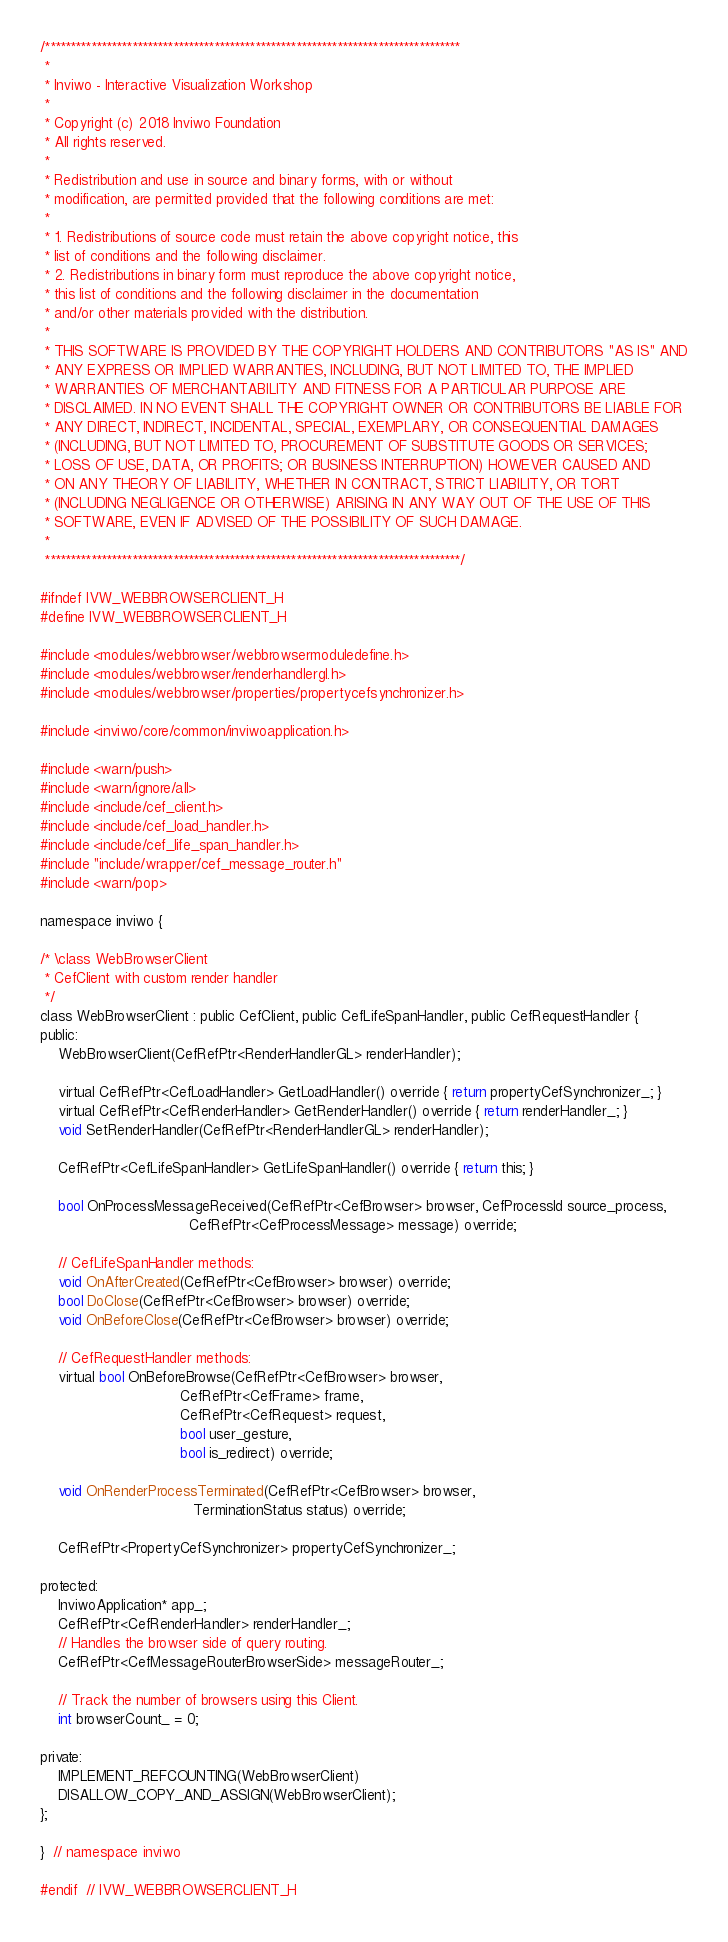Convert code to text. <code><loc_0><loc_0><loc_500><loc_500><_C_>/*********************************************************************************
 *
 * Inviwo - Interactive Visualization Workshop
 *
 * Copyright (c) 2018 Inviwo Foundation
 * All rights reserved.
 *
 * Redistribution and use in source and binary forms, with or without
 * modification, are permitted provided that the following conditions are met:
 *
 * 1. Redistributions of source code must retain the above copyright notice, this
 * list of conditions and the following disclaimer.
 * 2. Redistributions in binary form must reproduce the above copyright notice,
 * this list of conditions and the following disclaimer in the documentation
 * and/or other materials provided with the distribution.
 *
 * THIS SOFTWARE IS PROVIDED BY THE COPYRIGHT HOLDERS AND CONTRIBUTORS "AS IS" AND
 * ANY EXPRESS OR IMPLIED WARRANTIES, INCLUDING, BUT NOT LIMITED TO, THE IMPLIED
 * WARRANTIES OF MERCHANTABILITY AND FITNESS FOR A PARTICULAR PURPOSE ARE
 * DISCLAIMED. IN NO EVENT SHALL THE COPYRIGHT OWNER OR CONTRIBUTORS BE LIABLE FOR
 * ANY DIRECT, INDIRECT, INCIDENTAL, SPECIAL, EXEMPLARY, OR CONSEQUENTIAL DAMAGES
 * (INCLUDING, BUT NOT LIMITED TO, PROCUREMENT OF SUBSTITUTE GOODS OR SERVICES;
 * LOSS OF USE, DATA, OR PROFITS; OR BUSINESS INTERRUPTION) HOWEVER CAUSED AND
 * ON ANY THEORY OF LIABILITY, WHETHER IN CONTRACT, STRICT LIABILITY, OR TORT
 * (INCLUDING NEGLIGENCE OR OTHERWISE) ARISING IN ANY WAY OUT OF THE USE OF THIS
 * SOFTWARE, EVEN IF ADVISED OF THE POSSIBILITY OF SUCH DAMAGE.
 *
 *********************************************************************************/

#ifndef IVW_WEBBROWSERCLIENT_H
#define IVW_WEBBROWSERCLIENT_H

#include <modules/webbrowser/webbrowsermoduledefine.h>
#include <modules/webbrowser/renderhandlergl.h>
#include <modules/webbrowser/properties/propertycefsynchronizer.h>

#include <inviwo/core/common/inviwoapplication.h>

#include <warn/push>
#include <warn/ignore/all>
#include <include/cef_client.h>
#include <include/cef_load_handler.h>
#include <include/cef_life_span_handler.h>
#include "include/wrapper/cef_message_router.h"
#include <warn/pop>

namespace inviwo {

/* \class WebBrowserClient
 * CefClient with custom render handler
 */
class WebBrowserClient : public CefClient, public CefLifeSpanHandler, public CefRequestHandler {
public:
    WebBrowserClient(CefRefPtr<RenderHandlerGL> renderHandler);

    virtual CefRefPtr<CefLoadHandler> GetLoadHandler() override { return propertyCefSynchronizer_; }
    virtual CefRefPtr<CefRenderHandler> GetRenderHandler() override { return renderHandler_; }
    void SetRenderHandler(CefRefPtr<RenderHandlerGL> renderHandler);

    CefRefPtr<CefLifeSpanHandler> GetLifeSpanHandler() override { return this; }

    bool OnProcessMessageReceived(CefRefPtr<CefBrowser> browser, CefProcessId source_process,
                                  CefRefPtr<CefProcessMessage> message) override;

    // CefLifeSpanHandler methods:
    void OnAfterCreated(CefRefPtr<CefBrowser> browser) override;
    bool DoClose(CefRefPtr<CefBrowser> browser) override;
    void OnBeforeClose(CefRefPtr<CefBrowser> browser) override;

    // CefRequestHandler methods:
    virtual bool OnBeforeBrowse(CefRefPtr<CefBrowser> browser,
                                CefRefPtr<CefFrame> frame,
                                CefRefPtr<CefRequest> request,
                                bool user_gesture,
                                bool is_redirect) override;

    void OnRenderProcessTerminated(CefRefPtr<CefBrowser> browser,
                                   TerminationStatus status) override;

    CefRefPtr<PropertyCefSynchronizer> propertyCefSynchronizer_;

protected:
    InviwoApplication* app_;
    CefRefPtr<CefRenderHandler> renderHandler_;
    // Handles the browser side of query routing.
    CefRefPtr<CefMessageRouterBrowserSide> messageRouter_;

    // Track the number of browsers using this Client.
    int browserCount_ = 0;

private:
    IMPLEMENT_REFCOUNTING(WebBrowserClient)
    DISALLOW_COPY_AND_ASSIGN(WebBrowserClient);
};

}  // namespace inviwo

#endif  // IVW_WEBBROWSERCLIENT_H
</code> 